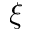Convert formula to latex. <formula><loc_0><loc_0><loc_500><loc_500>\xi</formula> 